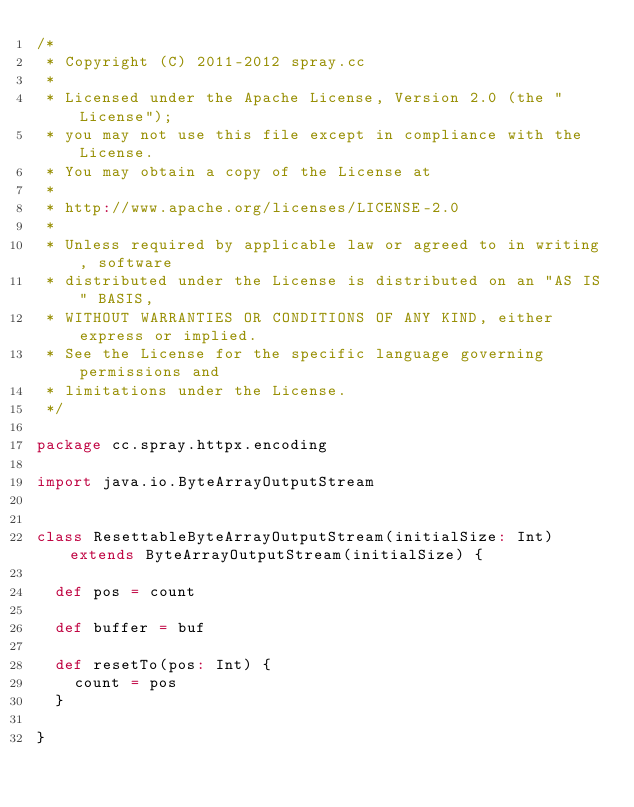Convert code to text. <code><loc_0><loc_0><loc_500><loc_500><_Scala_>/*
 * Copyright (C) 2011-2012 spray.cc
 *
 * Licensed under the Apache License, Version 2.0 (the "License");
 * you may not use this file except in compliance with the License.
 * You may obtain a copy of the License at
 *
 * http://www.apache.org/licenses/LICENSE-2.0
 *
 * Unless required by applicable law or agreed to in writing, software
 * distributed under the License is distributed on an "AS IS" BASIS,
 * WITHOUT WARRANTIES OR CONDITIONS OF ANY KIND, either express or implied.
 * See the License for the specific language governing permissions and
 * limitations under the License.
 */

package cc.spray.httpx.encoding

import java.io.ByteArrayOutputStream


class ResettableByteArrayOutputStream(initialSize: Int) extends ByteArrayOutputStream(initialSize) {

  def pos = count

  def buffer = buf

  def resetTo(pos: Int) {
    count = pos
  }

}</code> 